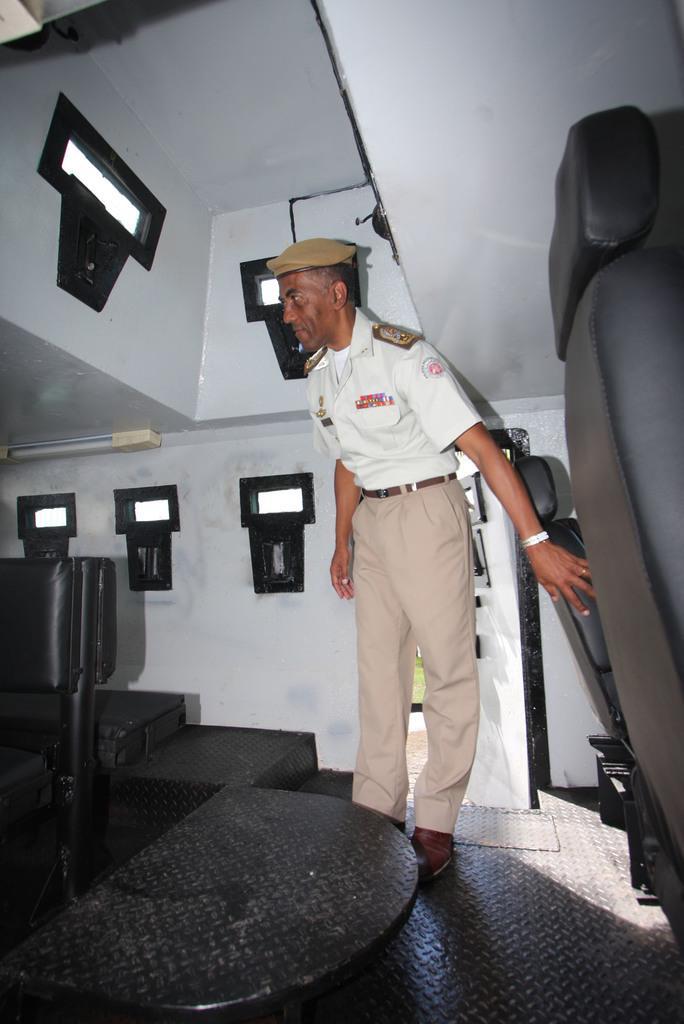Could you give a brief overview of what you see in this image? The picture taken inside a vehicle,a person is standing beside the the seats,he is wearing white shirt and a hat. 